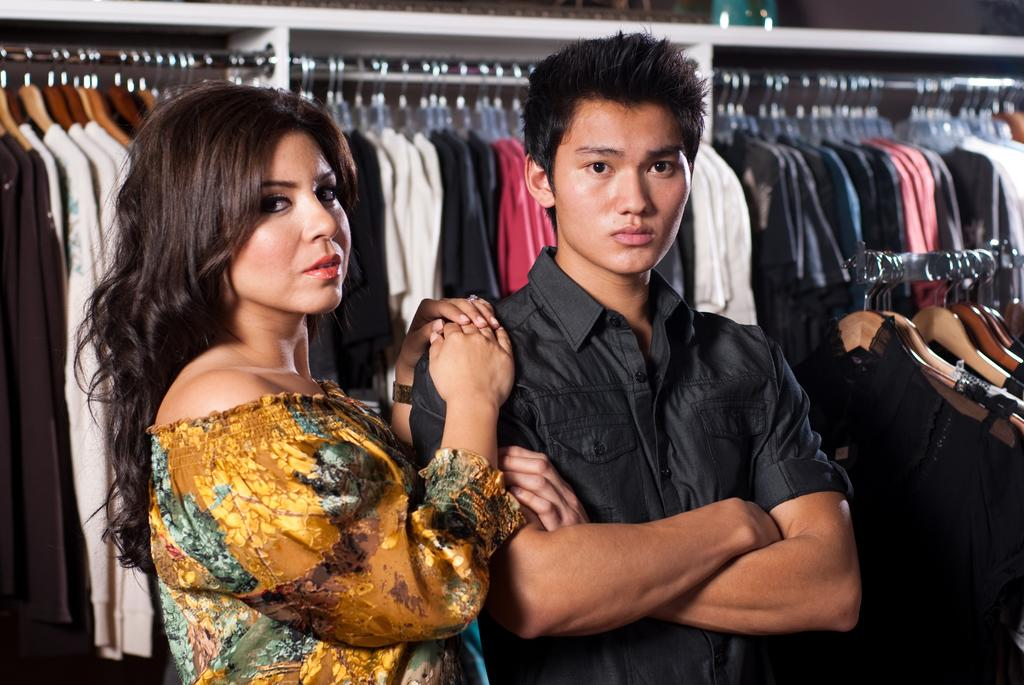Who can be seen in the image? There is a couple standing in the image. What is visible in the background of the image? There are clothes attached to a rod in the background of the image. What type of show is the couple attending in the image? There is no indication in the image that the couple is attending a show. 